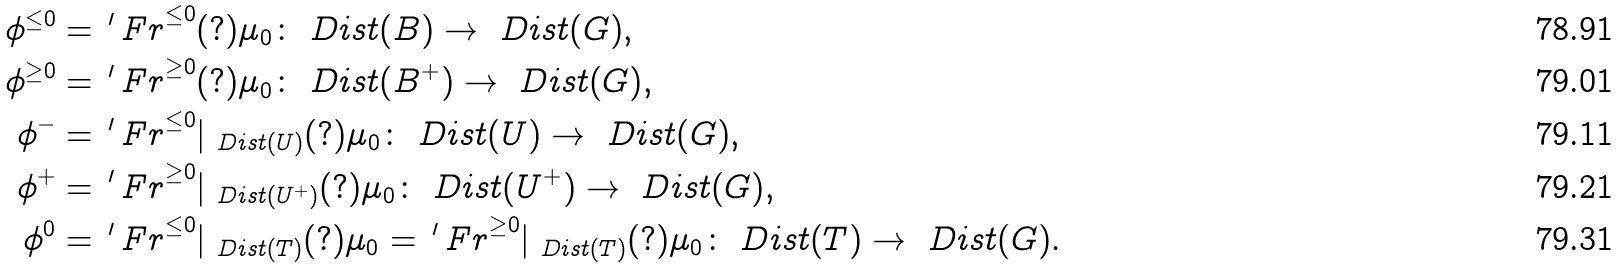Convert formula to latex. <formula><loc_0><loc_0><loc_500><loc_500>\phi ^ { \leq 0 } & = { \, ^ { \prime } \, F r } ^ { \leq 0 } ( ? ) \mu _ { 0 } \colon \ D i s t ( B ) \to \ D i s t ( G ) , \\ \phi ^ { \geq 0 } & = { \, ^ { \prime } \, F r } ^ { \geq 0 } ( ? ) \mu _ { 0 } \colon \ D i s t ( B ^ { + } ) \to \ D i s t ( G ) , \\ \phi ^ { - } & = { \, ^ { \prime } \, F r } ^ { \leq 0 } | _ { \ D i s t ( U ) } ( ? ) \mu _ { 0 } \colon \ D i s t ( U ) \to \ D i s t ( G ) , \\ \phi ^ { + } & = { \, ^ { \prime } \, F r } ^ { \geq 0 } | _ { \ D i s t ( U ^ { + } ) } ( ? ) \mu _ { 0 } \colon \ D i s t ( U ^ { + } ) \to \ D i s t ( G ) , \\ \phi ^ { 0 } & = { \, ^ { \prime } \, F r } ^ { \leq 0 } | _ { \ D i s t ( T ) } ( ? ) \mu _ { 0 } = { \, ^ { \prime } \, F r } ^ { \geq 0 } | _ { \ D i s t ( T ) } ( ? ) \mu _ { 0 } \colon \ D i s t ( T ) \to \ D i s t ( G ) .</formula> 